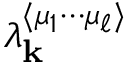Convert formula to latex. <formula><loc_0><loc_0><loc_500><loc_500>\lambda _ { k } ^ { \langle \mu _ { 1 } \cdots \mu _ { \ell } \rangle }</formula> 